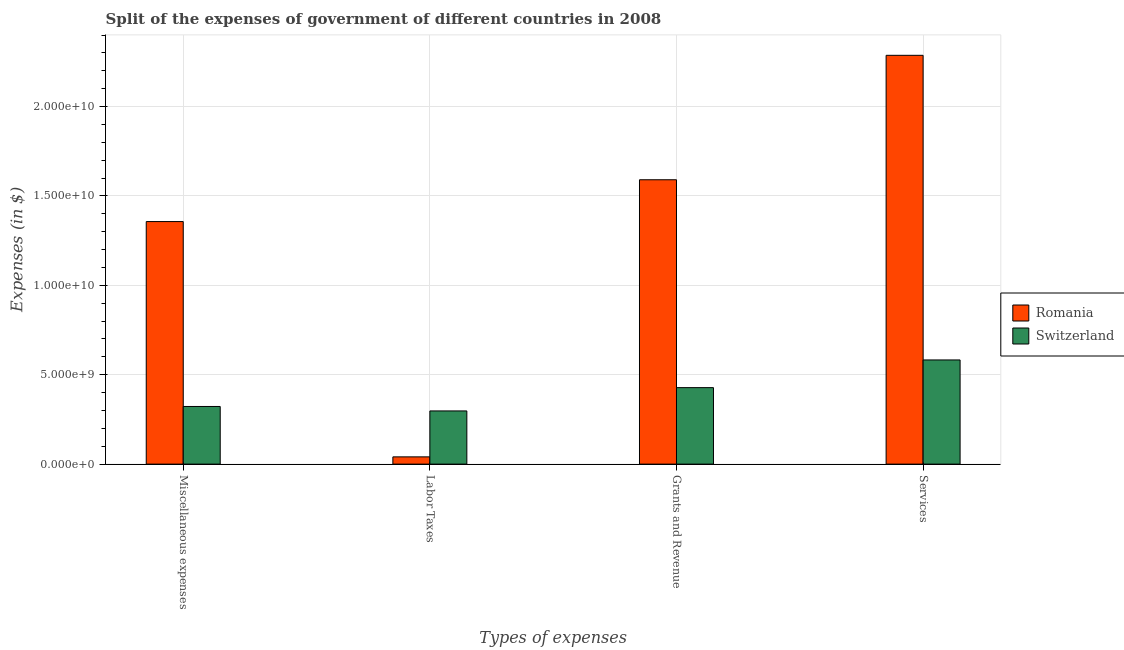How many groups of bars are there?
Offer a terse response. 4. Are the number of bars on each tick of the X-axis equal?
Give a very brief answer. Yes. How many bars are there on the 1st tick from the left?
Your response must be concise. 2. What is the label of the 2nd group of bars from the left?
Keep it short and to the point. Labor Taxes. What is the amount spent on grants and revenue in Romania?
Your answer should be compact. 1.59e+1. Across all countries, what is the maximum amount spent on miscellaneous expenses?
Provide a succinct answer. 1.36e+1. Across all countries, what is the minimum amount spent on grants and revenue?
Give a very brief answer. 4.28e+09. In which country was the amount spent on services maximum?
Offer a very short reply. Romania. In which country was the amount spent on grants and revenue minimum?
Provide a succinct answer. Switzerland. What is the total amount spent on miscellaneous expenses in the graph?
Make the answer very short. 1.68e+1. What is the difference between the amount spent on grants and revenue in Romania and that in Switzerland?
Make the answer very short. 1.16e+1. What is the difference between the amount spent on labor taxes in Romania and the amount spent on services in Switzerland?
Make the answer very short. -5.42e+09. What is the average amount spent on miscellaneous expenses per country?
Your answer should be very brief. 8.40e+09. What is the difference between the amount spent on miscellaneous expenses and amount spent on services in Switzerland?
Provide a short and direct response. -2.60e+09. What is the ratio of the amount spent on miscellaneous expenses in Switzerland to that in Romania?
Offer a very short reply. 0.24. Is the difference between the amount spent on miscellaneous expenses in Romania and Switzerland greater than the difference between the amount spent on grants and revenue in Romania and Switzerland?
Offer a very short reply. No. What is the difference between the highest and the second highest amount spent on labor taxes?
Make the answer very short. 2.57e+09. What is the difference between the highest and the lowest amount spent on labor taxes?
Your answer should be compact. 2.57e+09. Is the sum of the amount spent on miscellaneous expenses in Romania and Switzerland greater than the maximum amount spent on grants and revenue across all countries?
Your response must be concise. Yes. What does the 2nd bar from the left in Miscellaneous expenses represents?
Keep it short and to the point. Switzerland. What does the 1st bar from the right in Labor Taxes represents?
Provide a short and direct response. Switzerland. How many countries are there in the graph?
Your answer should be very brief. 2. Does the graph contain grids?
Ensure brevity in your answer.  Yes. Where does the legend appear in the graph?
Provide a short and direct response. Center right. How many legend labels are there?
Your response must be concise. 2. What is the title of the graph?
Provide a short and direct response. Split of the expenses of government of different countries in 2008. What is the label or title of the X-axis?
Provide a succinct answer. Types of expenses. What is the label or title of the Y-axis?
Ensure brevity in your answer.  Expenses (in $). What is the Expenses (in $) of Romania in Miscellaneous expenses?
Keep it short and to the point. 1.36e+1. What is the Expenses (in $) of Switzerland in Miscellaneous expenses?
Make the answer very short. 3.22e+09. What is the Expenses (in $) in Romania in Labor Taxes?
Offer a terse response. 4.05e+08. What is the Expenses (in $) in Switzerland in Labor Taxes?
Make the answer very short. 2.97e+09. What is the Expenses (in $) of Romania in Grants and Revenue?
Offer a terse response. 1.59e+1. What is the Expenses (in $) of Switzerland in Grants and Revenue?
Ensure brevity in your answer.  4.28e+09. What is the Expenses (in $) of Romania in Services?
Provide a succinct answer. 2.29e+1. What is the Expenses (in $) in Switzerland in Services?
Your response must be concise. 5.83e+09. Across all Types of expenses, what is the maximum Expenses (in $) of Romania?
Make the answer very short. 2.29e+1. Across all Types of expenses, what is the maximum Expenses (in $) of Switzerland?
Provide a short and direct response. 5.83e+09. Across all Types of expenses, what is the minimum Expenses (in $) in Romania?
Offer a very short reply. 4.05e+08. Across all Types of expenses, what is the minimum Expenses (in $) of Switzerland?
Provide a succinct answer. 2.97e+09. What is the total Expenses (in $) of Romania in the graph?
Provide a succinct answer. 5.27e+1. What is the total Expenses (in $) in Switzerland in the graph?
Keep it short and to the point. 1.63e+1. What is the difference between the Expenses (in $) of Romania in Miscellaneous expenses and that in Labor Taxes?
Give a very brief answer. 1.32e+1. What is the difference between the Expenses (in $) of Switzerland in Miscellaneous expenses and that in Labor Taxes?
Provide a short and direct response. 2.49e+08. What is the difference between the Expenses (in $) in Romania in Miscellaneous expenses and that in Grants and Revenue?
Offer a terse response. -2.34e+09. What is the difference between the Expenses (in $) of Switzerland in Miscellaneous expenses and that in Grants and Revenue?
Your response must be concise. -1.05e+09. What is the difference between the Expenses (in $) of Romania in Miscellaneous expenses and that in Services?
Provide a succinct answer. -9.30e+09. What is the difference between the Expenses (in $) of Switzerland in Miscellaneous expenses and that in Services?
Offer a terse response. -2.60e+09. What is the difference between the Expenses (in $) in Romania in Labor Taxes and that in Grants and Revenue?
Your answer should be very brief. -1.55e+1. What is the difference between the Expenses (in $) of Switzerland in Labor Taxes and that in Grants and Revenue?
Provide a succinct answer. -1.30e+09. What is the difference between the Expenses (in $) of Romania in Labor Taxes and that in Services?
Keep it short and to the point. -2.25e+1. What is the difference between the Expenses (in $) of Switzerland in Labor Taxes and that in Services?
Your answer should be compact. -2.85e+09. What is the difference between the Expenses (in $) in Romania in Grants and Revenue and that in Services?
Keep it short and to the point. -6.96e+09. What is the difference between the Expenses (in $) of Switzerland in Grants and Revenue and that in Services?
Provide a succinct answer. -1.55e+09. What is the difference between the Expenses (in $) in Romania in Miscellaneous expenses and the Expenses (in $) in Switzerland in Labor Taxes?
Provide a succinct answer. 1.06e+1. What is the difference between the Expenses (in $) in Romania in Miscellaneous expenses and the Expenses (in $) in Switzerland in Grants and Revenue?
Your answer should be compact. 9.29e+09. What is the difference between the Expenses (in $) of Romania in Miscellaneous expenses and the Expenses (in $) of Switzerland in Services?
Offer a very short reply. 7.74e+09. What is the difference between the Expenses (in $) in Romania in Labor Taxes and the Expenses (in $) in Switzerland in Grants and Revenue?
Your answer should be very brief. -3.87e+09. What is the difference between the Expenses (in $) of Romania in Labor Taxes and the Expenses (in $) of Switzerland in Services?
Keep it short and to the point. -5.42e+09. What is the difference between the Expenses (in $) of Romania in Grants and Revenue and the Expenses (in $) of Switzerland in Services?
Offer a terse response. 1.01e+1. What is the average Expenses (in $) in Romania per Types of expenses?
Your answer should be very brief. 1.32e+1. What is the average Expenses (in $) of Switzerland per Types of expenses?
Ensure brevity in your answer.  4.08e+09. What is the difference between the Expenses (in $) of Romania and Expenses (in $) of Switzerland in Miscellaneous expenses?
Make the answer very short. 1.03e+1. What is the difference between the Expenses (in $) in Romania and Expenses (in $) in Switzerland in Labor Taxes?
Give a very brief answer. -2.57e+09. What is the difference between the Expenses (in $) in Romania and Expenses (in $) in Switzerland in Grants and Revenue?
Ensure brevity in your answer.  1.16e+1. What is the difference between the Expenses (in $) in Romania and Expenses (in $) in Switzerland in Services?
Ensure brevity in your answer.  1.70e+1. What is the ratio of the Expenses (in $) of Romania in Miscellaneous expenses to that in Labor Taxes?
Offer a terse response. 33.49. What is the ratio of the Expenses (in $) in Switzerland in Miscellaneous expenses to that in Labor Taxes?
Offer a terse response. 1.08. What is the ratio of the Expenses (in $) of Romania in Miscellaneous expenses to that in Grants and Revenue?
Make the answer very short. 0.85. What is the ratio of the Expenses (in $) in Switzerland in Miscellaneous expenses to that in Grants and Revenue?
Offer a very short reply. 0.75. What is the ratio of the Expenses (in $) in Romania in Miscellaneous expenses to that in Services?
Offer a very short reply. 0.59. What is the ratio of the Expenses (in $) in Switzerland in Miscellaneous expenses to that in Services?
Offer a very short reply. 0.55. What is the ratio of the Expenses (in $) in Romania in Labor Taxes to that in Grants and Revenue?
Your response must be concise. 0.03. What is the ratio of the Expenses (in $) of Switzerland in Labor Taxes to that in Grants and Revenue?
Provide a short and direct response. 0.7. What is the ratio of the Expenses (in $) of Romania in Labor Taxes to that in Services?
Ensure brevity in your answer.  0.02. What is the ratio of the Expenses (in $) in Switzerland in Labor Taxes to that in Services?
Your answer should be compact. 0.51. What is the ratio of the Expenses (in $) of Romania in Grants and Revenue to that in Services?
Provide a short and direct response. 0.7. What is the ratio of the Expenses (in $) of Switzerland in Grants and Revenue to that in Services?
Offer a terse response. 0.73. What is the difference between the highest and the second highest Expenses (in $) of Romania?
Give a very brief answer. 6.96e+09. What is the difference between the highest and the second highest Expenses (in $) of Switzerland?
Your response must be concise. 1.55e+09. What is the difference between the highest and the lowest Expenses (in $) in Romania?
Offer a very short reply. 2.25e+1. What is the difference between the highest and the lowest Expenses (in $) in Switzerland?
Keep it short and to the point. 2.85e+09. 